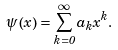Convert formula to latex. <formula><loc_0><loc_0><loc_500><loc_500>\psi \left ( x \right ) = \sum _ { k = 0 } ^ { \infty } a _ { k } x ^ { k } .</formula> 